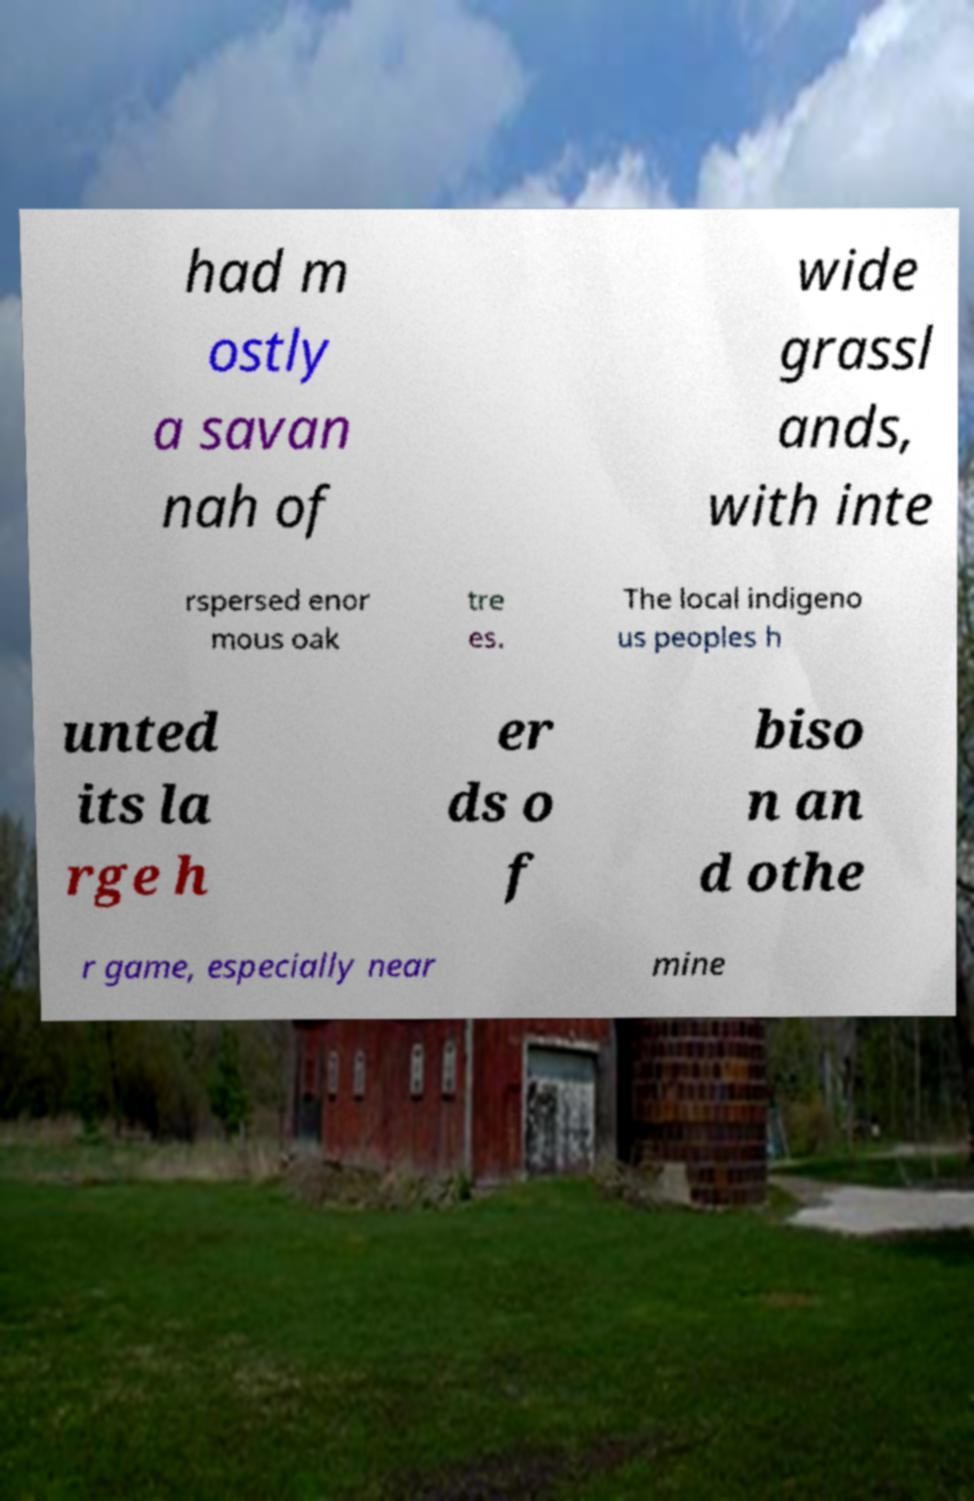Could you extract and type out the text from this image? had m ostly a savan nah of wide grassl ands, with inte rspersed enor mous oak tre es. The local indigeno us peoples h unted its la rge h er ds o f biso n an d othe r game, especially near mine 